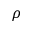Convert formula to latex. <formula><loc_0><loc_0><loc_500><loc_500>\rho</formula> 